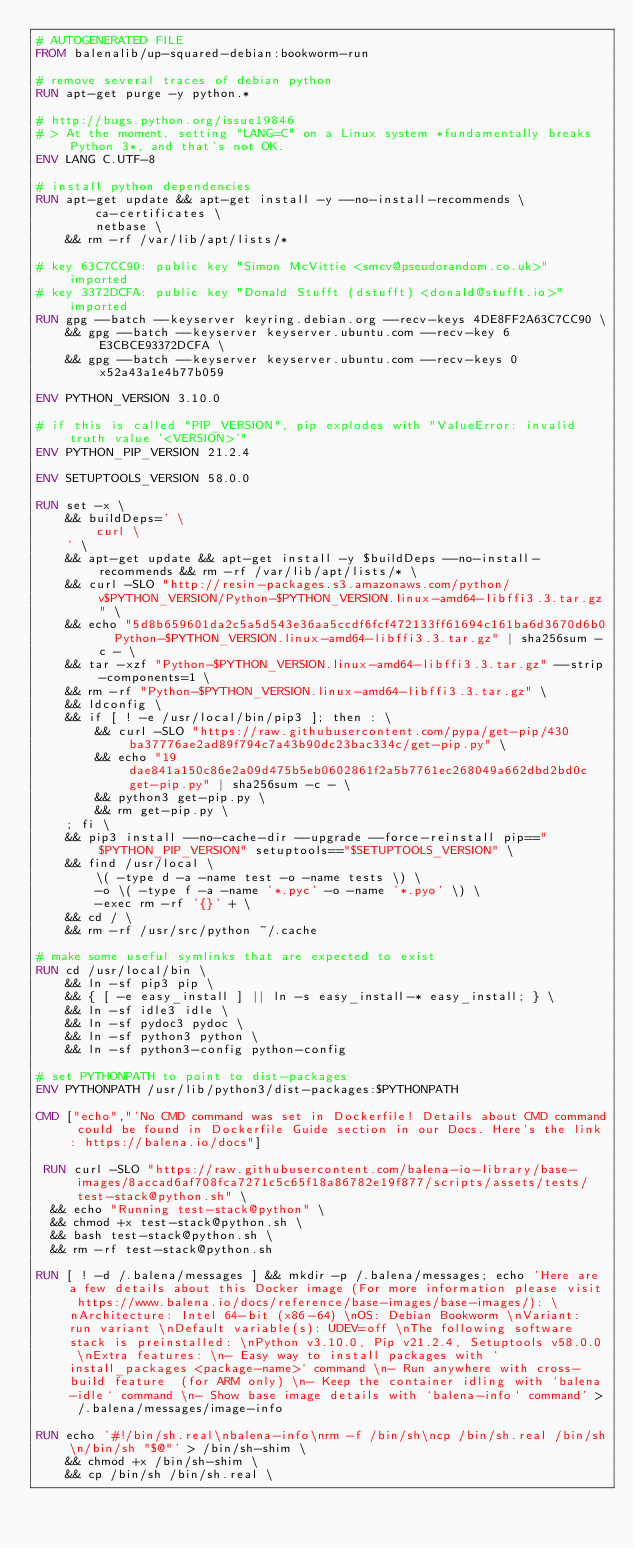Convert code to text. <code><loc_0><loc_0><loc_500><loc_500><_Dockerfile_># AUTOGENERATED FILE
FROM balenalib/up-squared-debian:bookworm-run

# remove several traces of debian python
RUN apt-get purge -y python.*

# http://bugs.python.org/issue19846
# > At the moment, setting "LANG=C" on a Linux system *fundamentally breaks Python 3*, and that's not OK.
ENV LANG C.UTF-8

# install python dependencies
RUN apt-get update && apt-get install -y --no-install-recommends \
		ca-certificates \
		netbase \
	&& rm -rf /var/lib/apt/lists/*

# key 63C7CC90: public key "Simon McVittie <smcv@pseudorandom.co.uk>" imported
# key 3372DCFA: public key "Donald Stufft (dstufft) <donald@stufft.io>" imported
RUN gpg --batch --keyserver keyring.debian.org --recv-keys 4DE8FF2A63C7CC90 \
	&& gpg --batch --keyserver keyserver.ubuntu.com --recv-key 6E3CBCE93372DCFA \
	&& gpg --batch --keyserver keyserver.ubuntu.com --recv-keys 0x52a43a1e4b77b059

ENV PYTHON_VERSION 3.10.0

# if this is called "PIP_VERSION", pip explodes with "ValueError: invalid truth value '<VERSION>'"
ENV PYTHON_PIP_VERSION 21.2.4

ENV SETUPTOOLS_VERSION 58.0.0

RUN set -x \
	&& buildDeps=' \
		curl \
	' \
	&& apt-get update && apt-get install -y $buildDeps --no-install-recommends && rm -rf /var/lib/apt/lists/* \
	&& curl -SLO "http://resin-packages.s3.amazonaws.com/python/v$PYTHON_VERSION/Python-$PYTHON_VERSION.linux-amd64-libffi3.3.tar.gz" \
	&& echo "5d8b659601da2c5a5d543e36aa5ccdf6fcf472133ff61694c161ba6d3670d6b0  Python-$PYTHON_VERSION.linux-amd64-libffi3.3.tar.gz" | sha256sum -c - \
	&& tar -xzf "Python-$PYTHON_VERSION.linux-amd64-libffi3.3.tar.gz" --strip-components=1 \
	&& rm -rf "Python-$PYTHON_VERSION.linux-amd64-libffi3.3.tar.gz" \
	&& ldconfig \
	&& if [ ! -e /usr/local/bin/pip3 ]; then : \
		&& curl -SLO "https://raw.githubusercontent.com/pypa/get-pip/430ba37776ae2ad89f794c7a43b90dc23bac334c/get-pip.py" \
		&& echo "19dae841a150c86e2a09d475b5eb0602861f2a5b7761ec268049a662dbd2bd0c  get-pip.py" | sha256sum -c - \
		&& python3 get-pip.py \
		&& rm get-pip.py \
	; fi \
	&& pip3 install --no-cache-dir --upgrade --force-reinstall pip=="$PYTHON_PIP_VERSION" setuptools=="$SETUPTOOLS_VERSION" \
	&& find /usr/local \
		\( -type d -a -name test -o -name tests \) \
		-o \( -type f -a -name '*.pyc' -o -name '*.pyo' \) \
		-exec rm -rf '{}' + \
	&& cd / \
	&& rm -rf /usr/src/python ~/.cache

# make some useful symlinks that are expected to exist
RUN cd /usr/local/bin \
	&& ln -sf pip3 pip \
	&& { [ -e easy_install ] || ln -s easy_install-* easy_install; } \
	&& ln -sf idle3 idle \
	&& ln -sf pydoc3 pydoc \
	&& ln -sf python3 python \
	&& ln -sf python3-config python-config

# set PYTHONPATH to point to dist-packages
ENV PYTHONPATH /usr/lib/python3/dist-packages:$PYTHONPATH

CMD ["echo","'No CMD command was set in Dockerfile! Details about CMD command could be found in Dockerfile Guide section in our Docs. Here's the link: https://balena.io/docs"]

 RUN curl -SLO "https://raw.githubusercontent.com/balena-io-library/base-images/8accad6af708fca7271c5c65f18a86782e19f877/scripts/assets/tests/test-stack@python.sh" \
  && echo "Running test-stack@python" \
  && chmod +x test-stack@python.sh \
  && bash test-stack@python.sh \
  && rm -rf test-stack@python.sh 

RUN [ ! -d /.balena/messages ] && mkdir -p /.balena/messages; echo 'Here are a few details about this Docker image (For more information please visit https://www.balena.io/docs/reference/base-images/base-images/): \nArchitecture: Intel 64-bit (x86-64) \nOS: Debian Bookworm \nVariant: run variant \nDefault variable(s): UDEV=off \nThe following software stack is preinstalled: \nPython v3.10.0, Pip v21.2.4, Setuptools v58.0.0 \nExtra features: \n- Easy way to install packages with `install_packages <package-name>` command \n- Run anywhere with cross-build feature  (for ARM only) \n- Keep the container idling with `balena-idle` command \n- Show base image details with `balena-info` command' > /.balena/messages/image-info

RUN echo '#!/bin/sh.real\nbalena-info\nrm -f /bin/sh\ncp /bin/sh.real /bin/sh\n/bin/sh "$@"' > /bin/sh-shim \
	&& chmod +x /bin/sh-shim \
	&& cp /bin/sh /bin/sh.real \</code> 